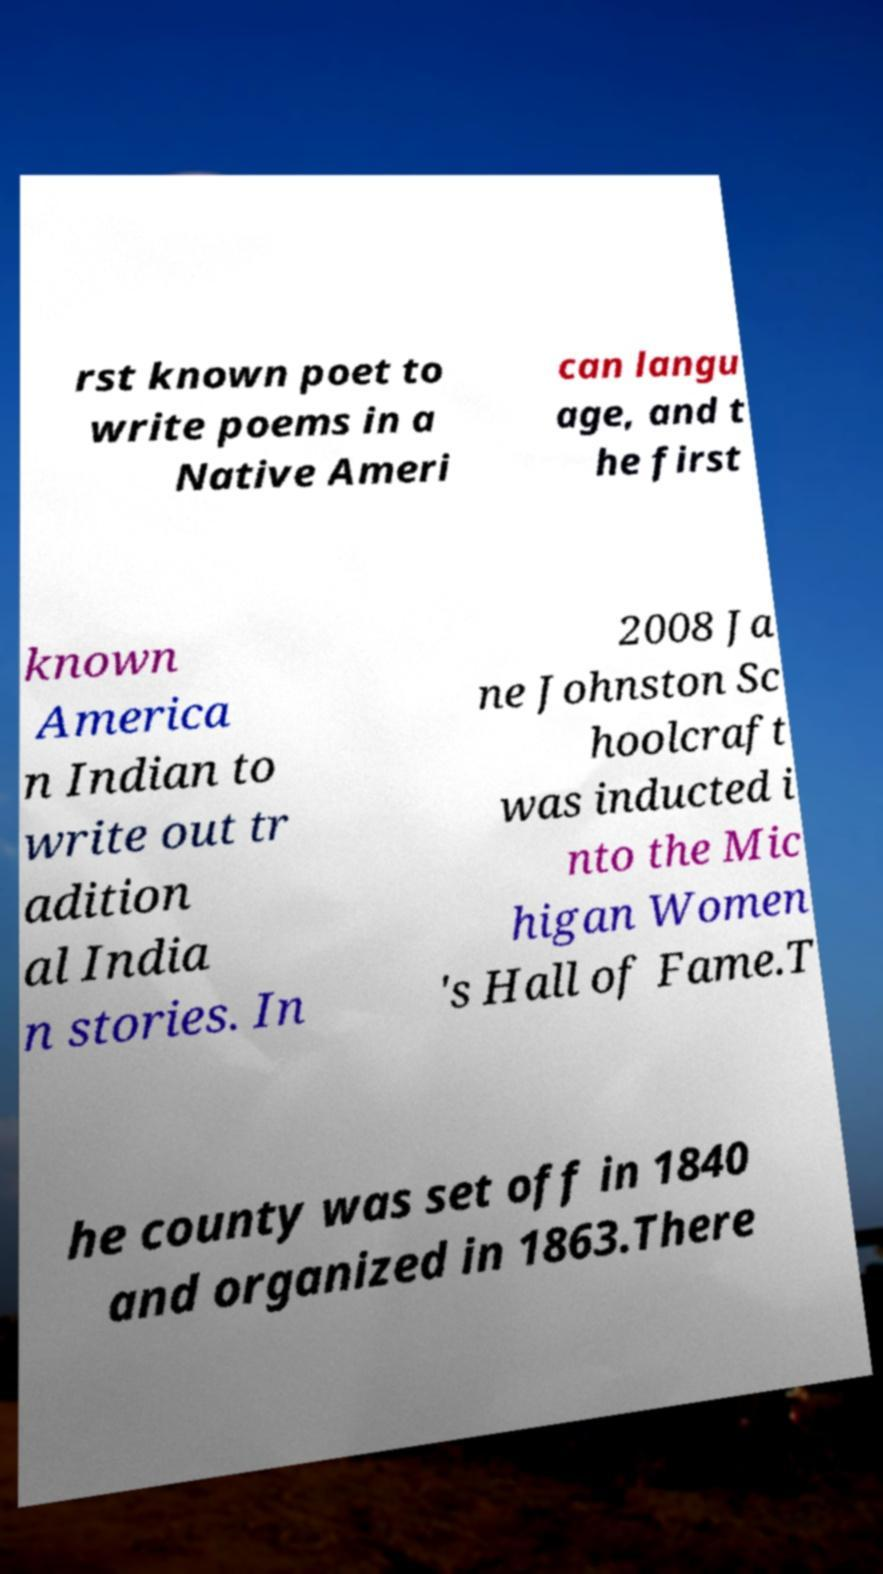There's text embedded in this image that I need extracted. Can you transcribe it verbatim? rst known poet to write poems in a Native Ameri can langu age, and t he first known America n Indian to write out tr adition al India n stories. In 2008 Ja ne Johnston Sc hoolcraft was inducted i nto the Mic higan Women 's Hall of Fame.T he county was set off in 1840 and organized in 1863.There 